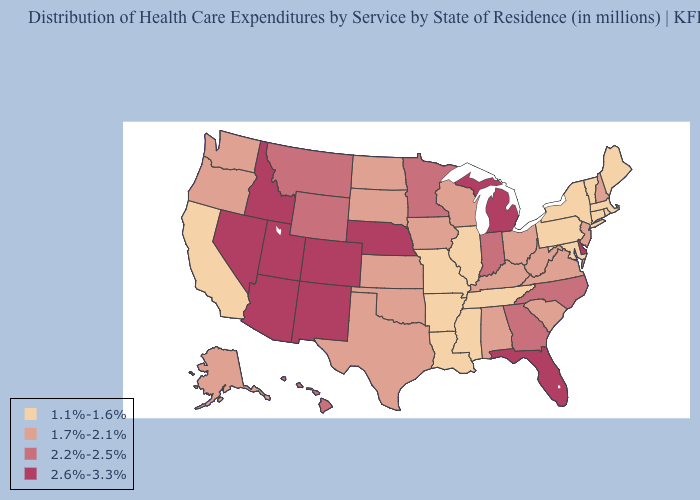Is the legend a continuous bar?
Concise answer only. No. Does the map have missing data?
Write a very short answer. No. Name the states that have a value in the range 2.6%-3.3%?
Short answer required. Arizona, Colorado, Delaware, Florida, Idaho, Michigan, Nebraska, Nevada, New Mexico, Utah. What is the value of New Hampshire?
Write a very short answer. 1.7%-2.1%. Name the states that have a value in the range 2.6%-3.3%?
Give a very brief answer. Arizona, Colorado, Delaware, Florida, Idaho, Michigan, Nebraska, Nevada, New Mexico, Utah. Which states hav the highest value in the West?
Concise answer only. Arizona, Colorado, Idaho, Nevada, New Mexico, Utah. Does Connecticut have the lowest value in the USA?
Concise answer only. Yes. What is the value of Utah?
Answer briefly. 2.6%-3.3%. Does Virginia have the highest value in the USA?
Answer briefly. No. Name the states that have a value in the range 1.1%-1.6%?
Quick response, please. Arkansas, California, Connecticut, Illinois, Louisiana, Maine, Maryland, Massachusetts, Mississippi, Missouri, New York, Pennsylvania, Rhode Island, Tennessee, Vermont. Which states have the lowest value in the USA?
Concise answer only. Arkansas, California, Connecticut, Illinois, Louisiana, Maine, Maryland, Massachusetts, Mississippi, Missouri, New York, Pennsylvania, Rhode Island, Tennessee, Vermont. What is the value of Montana?
Short answer required. 2.2%-2.5%. Does Arkansas have the lowest value in the South?
Concise answer only. Yes. What is the value of Nevada?
Keep it brief. 2.6%-3.3%. 